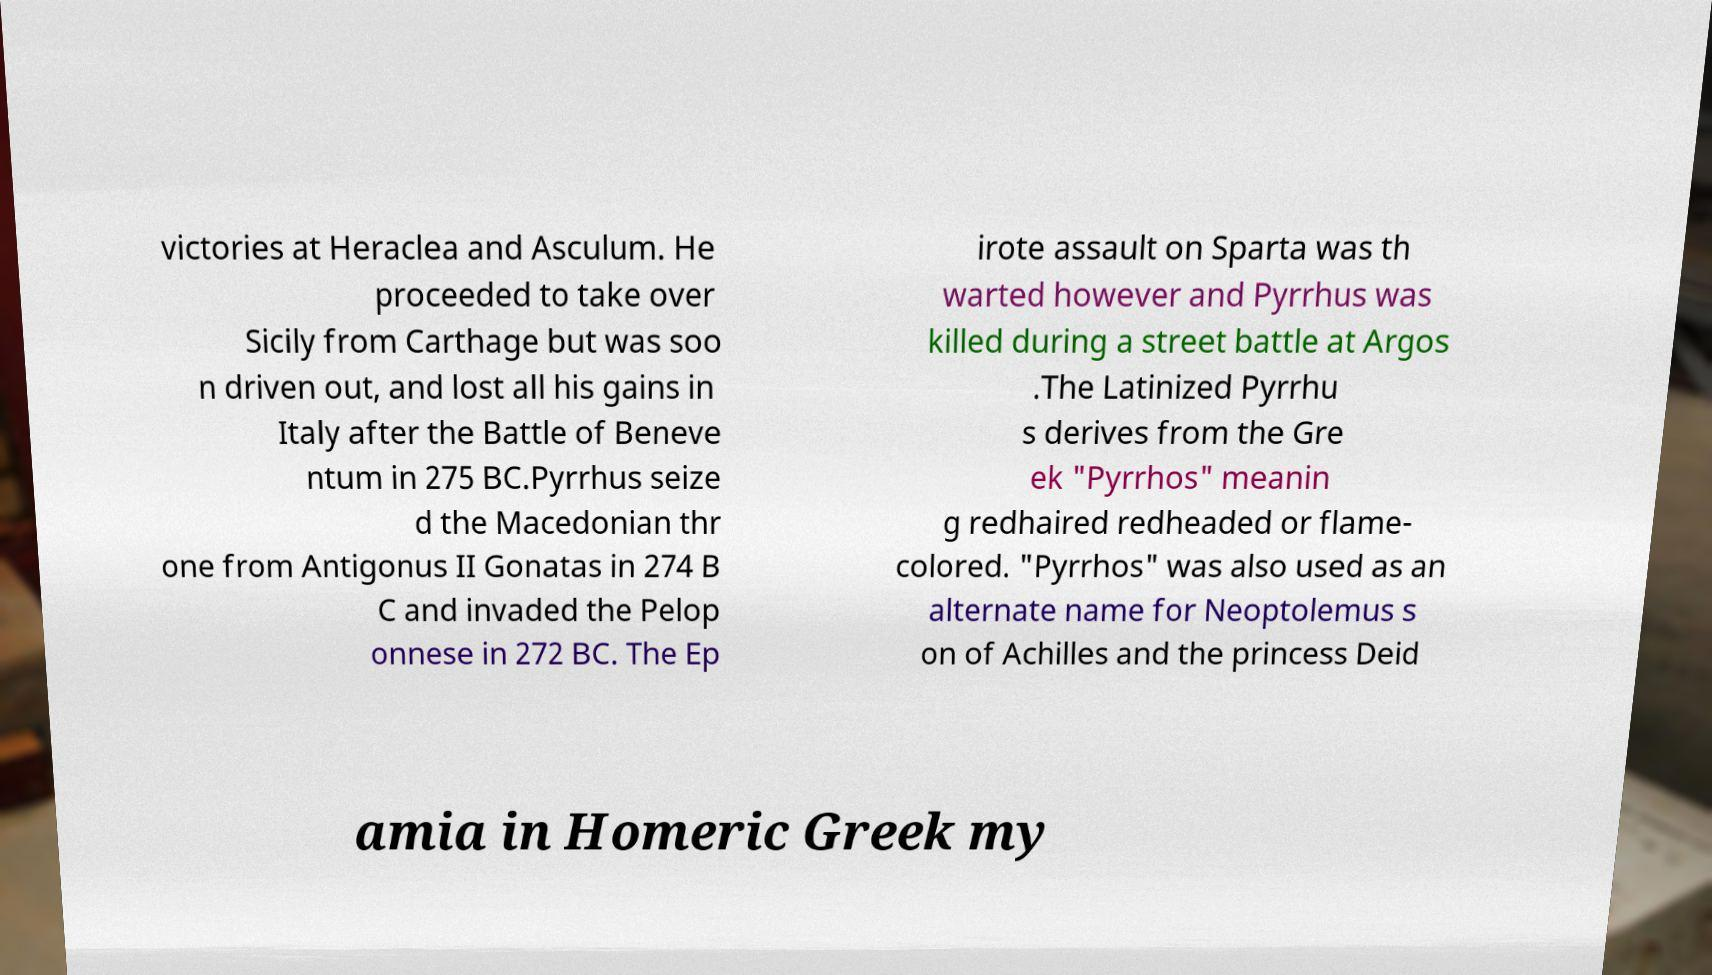For documentation purposes, I need the text within this image transcribed. Could you provide that? victories at Heraclea and Asculum. He proceeded to take over Sicily from Carthage but was soo n driven out, and lost all his gains in Italy after the Battle of Beneve ntum in 275 BC.Pyrrhus seize d the Macedonian thr one from Antigonus II Gonatas in 274 B C and invaded the Pelop onnese in 272 BC. The Ep irote assault on Sparta was th warted however and Pyrrhus was killed during a street battle at Argos .The Latinized Pyrrhu s derives from the Gre ek "Pyrrhos" meanin g redhaired redheaded or flame- colored. "Pyrrhos" was also used as an alternate name for Neoptolemus s on of Achilles and the princess Deid amia in Homeric Greek my 